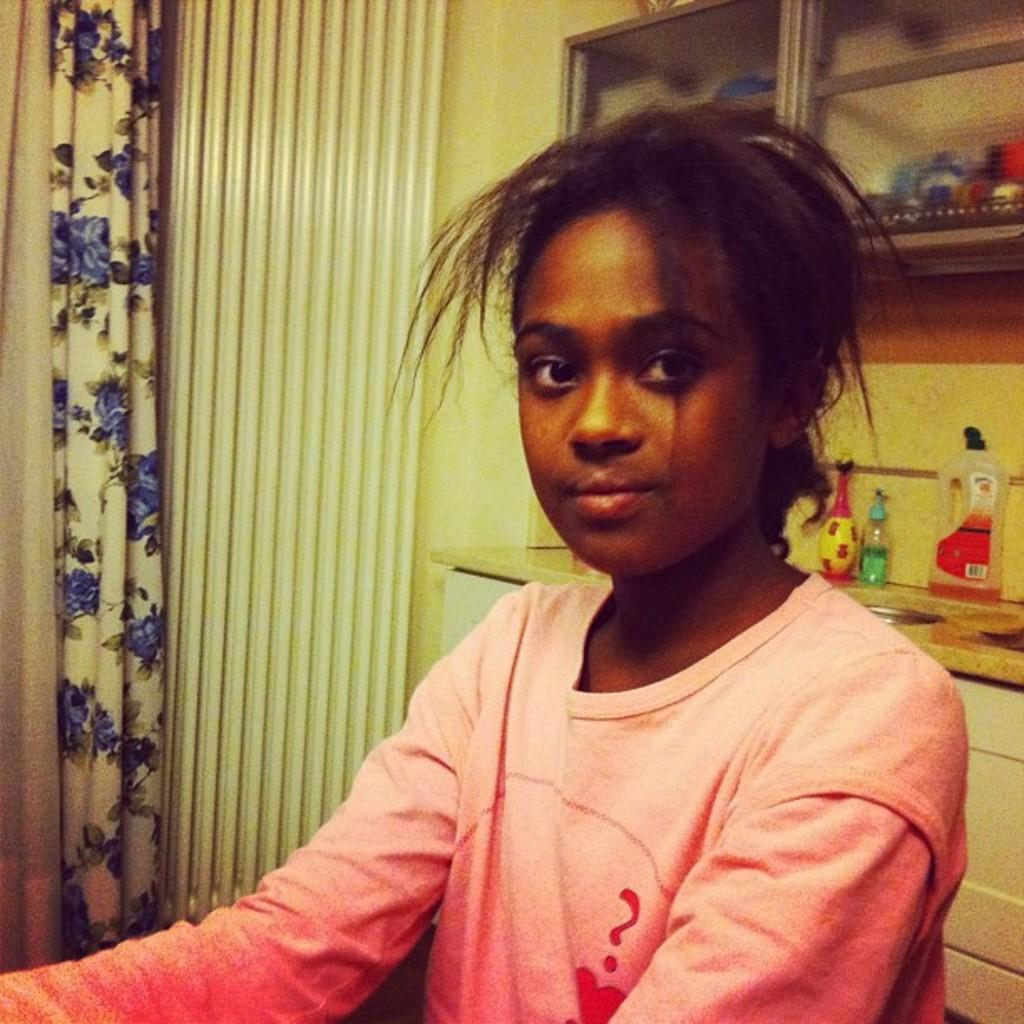Who is the main subject in the image? There is a girl in the image. What can be seen in the background of the image? There is a wall, a curtain, bottles on a sink table, and objects in a cupboard with glass doors in the background of the image. What type of goat can be seen attending the party in the image? There is no goat or party present in the image. How does the girl react to the news of death in the image? There is no mention of death or any reaction to it in the image. 